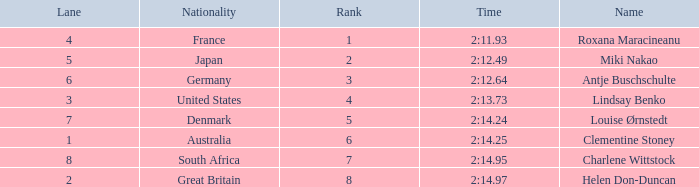What shows for nationality when there is a rank larger than 6, and a Time of 2:14.95? South Africa. 